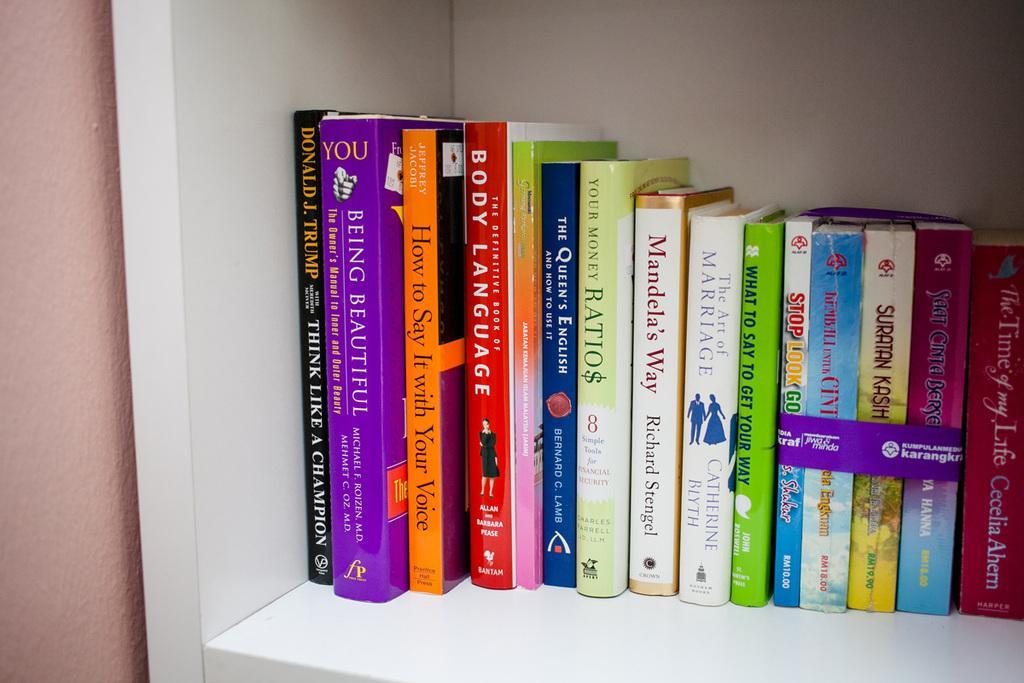Describe this image in one or two sentences. In this image I can see many colorful books in the white color shelf. To the left I can see the wall. 